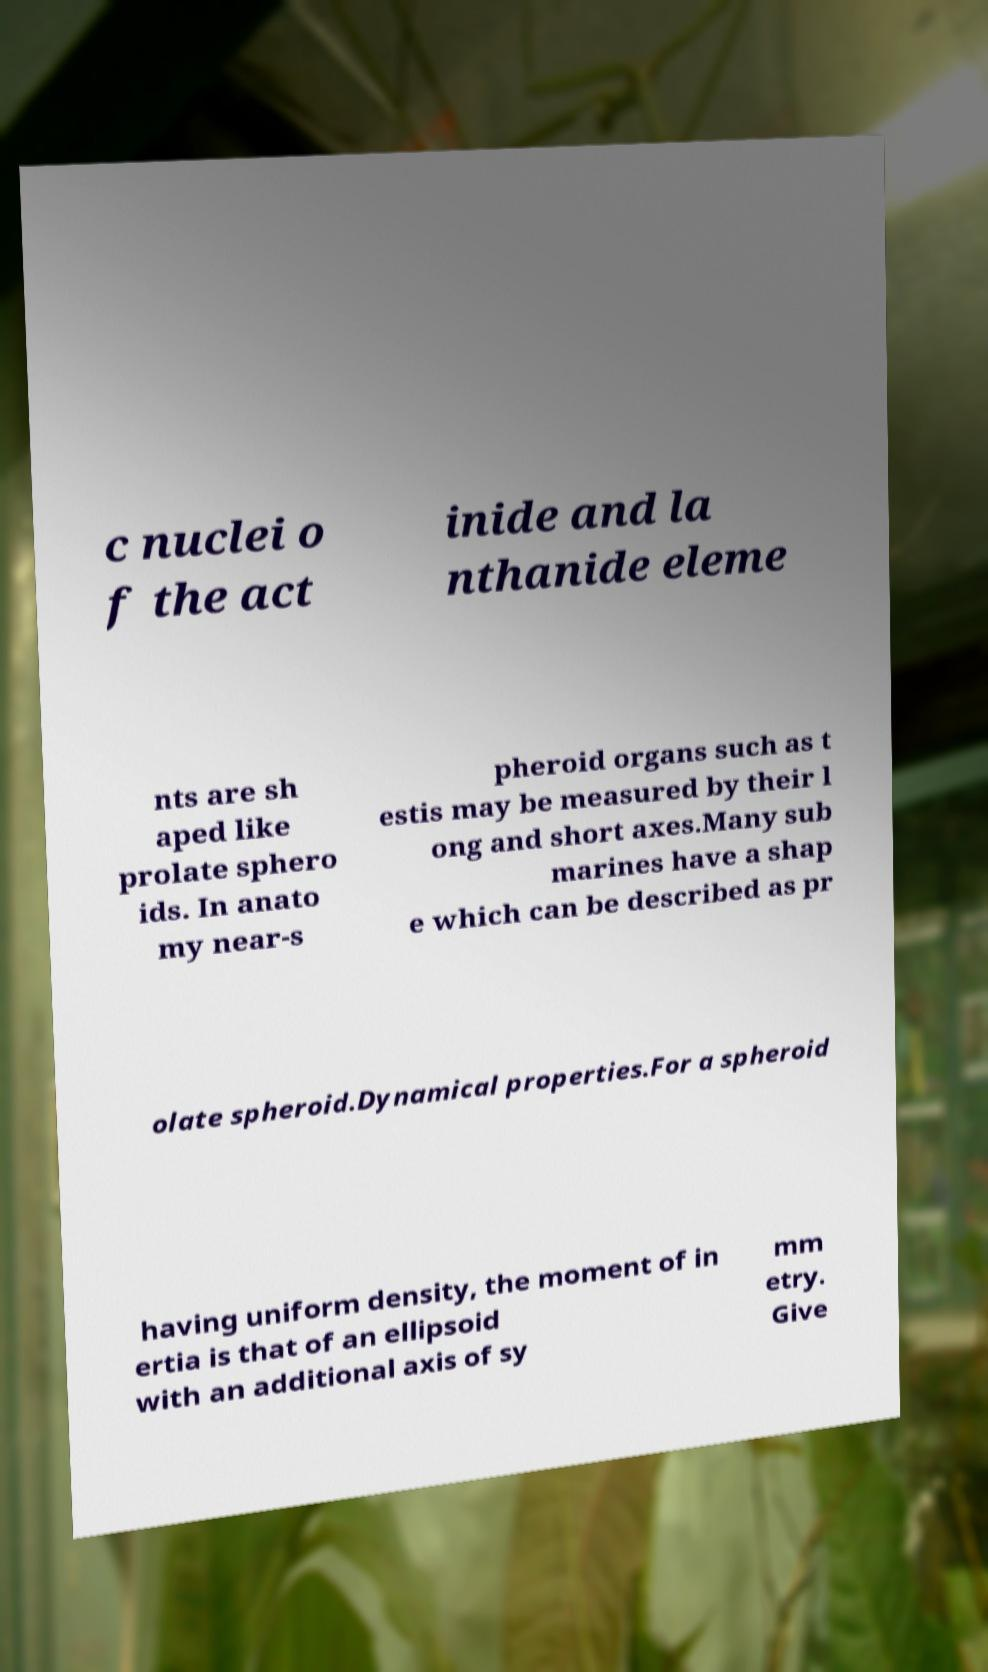Could you extract and type out the text from this image? c nuclei o f the act inide and la nthanide eleme nts are sh aped like prolate sphero ids. In anato my near-s pheroid organs such as t estis may be measured by their l ong and short axes.Many sub marines have a shap e which can be described as pr olate spheroid.Dynamical properties.For a spheroid having uniform density, the moment of in ertia is that of an ellipsoid with an additional axis of sy mm etry. Give 